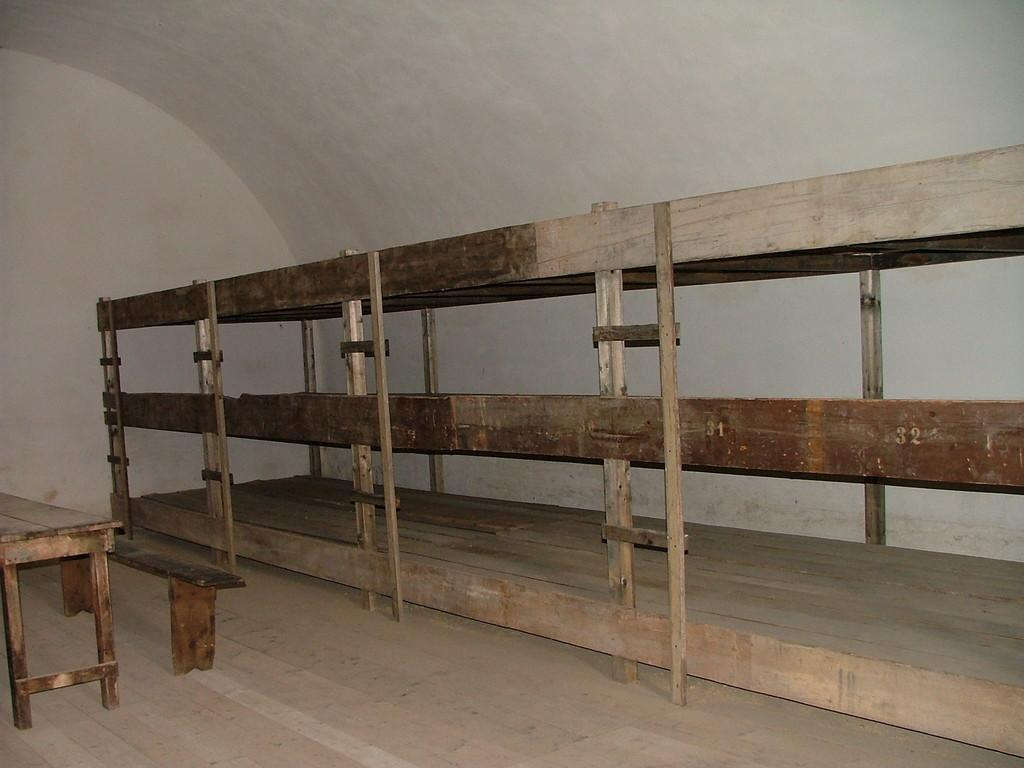What type of seating is available in the room? There are benches in the room. What material is used for the railing in the room? The wooden railing is in the room. How many bags are hanging on the wooden railing in the image? There are no bags present in the image; it only features benches and a wooden railing. What type of knot is used to secure the wooden railing to the wall? There is no knot visible in the image, as the wooden railing appears to be attached to the wall in a different manner. 